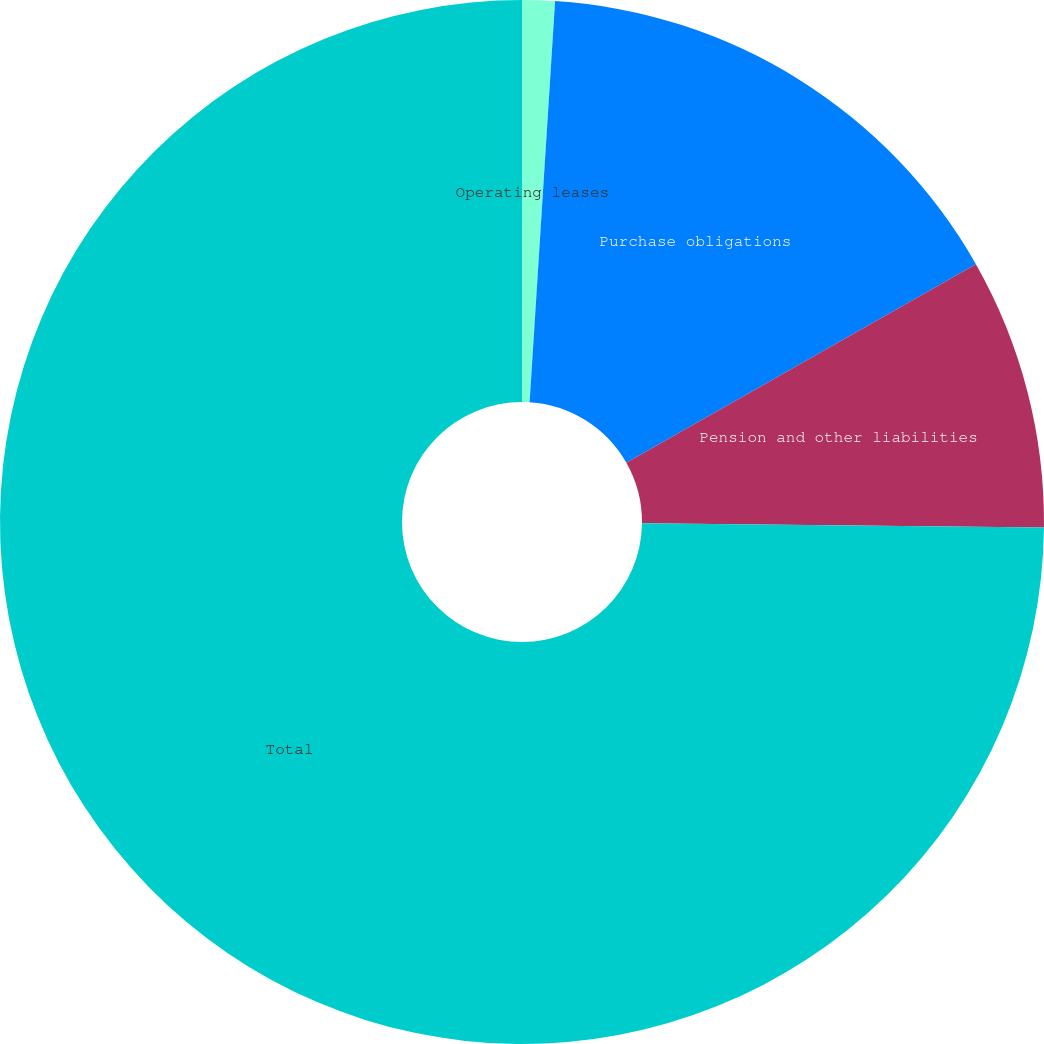Convert chart to OTSL. <chart><loc_0><loc_0><loc_500><loc_500><pie_chart><fcel>Operating leases<fcel>Purchase obligations<fcel>Pension and other liabilities<fcel>Total<nl><fcel>1.01%<fcel>15.77%<fcel>8.39%<fcel>74.83%<nl></chart> 